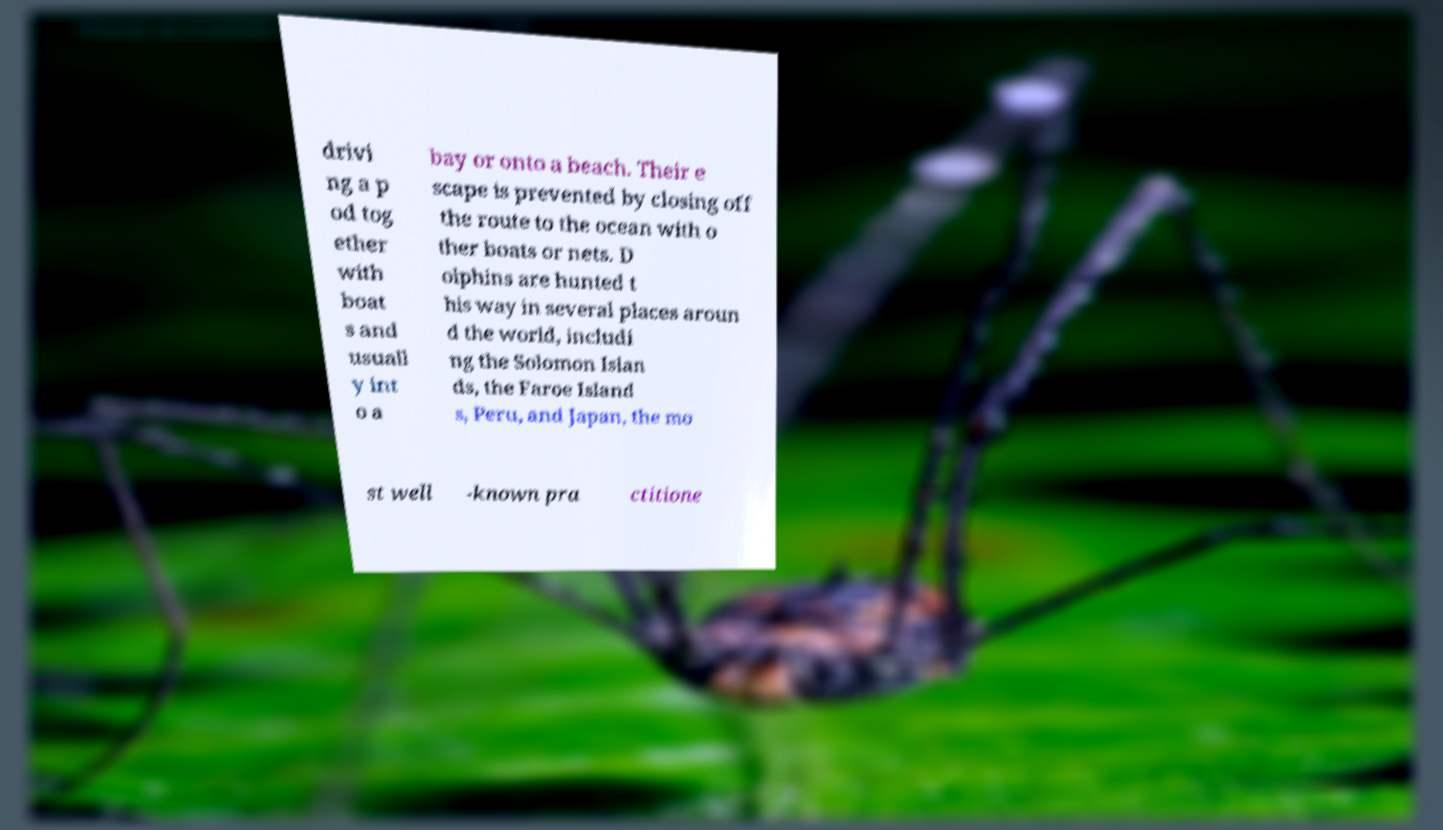I need the written content from this picture converted into text. Can you do that? drivi ng a p od tog ether with boat s and usuall y int o a bay or onto a beach. Their e scape is prevented by closing off the route to the ocean with o ther boats or nets. D olphins are hunted t his way in several places aroun d the world, includi ng the Solomon Islan ds, the Faroe Island s, Peru, and Japan, the mo st well -known pra ctitione 